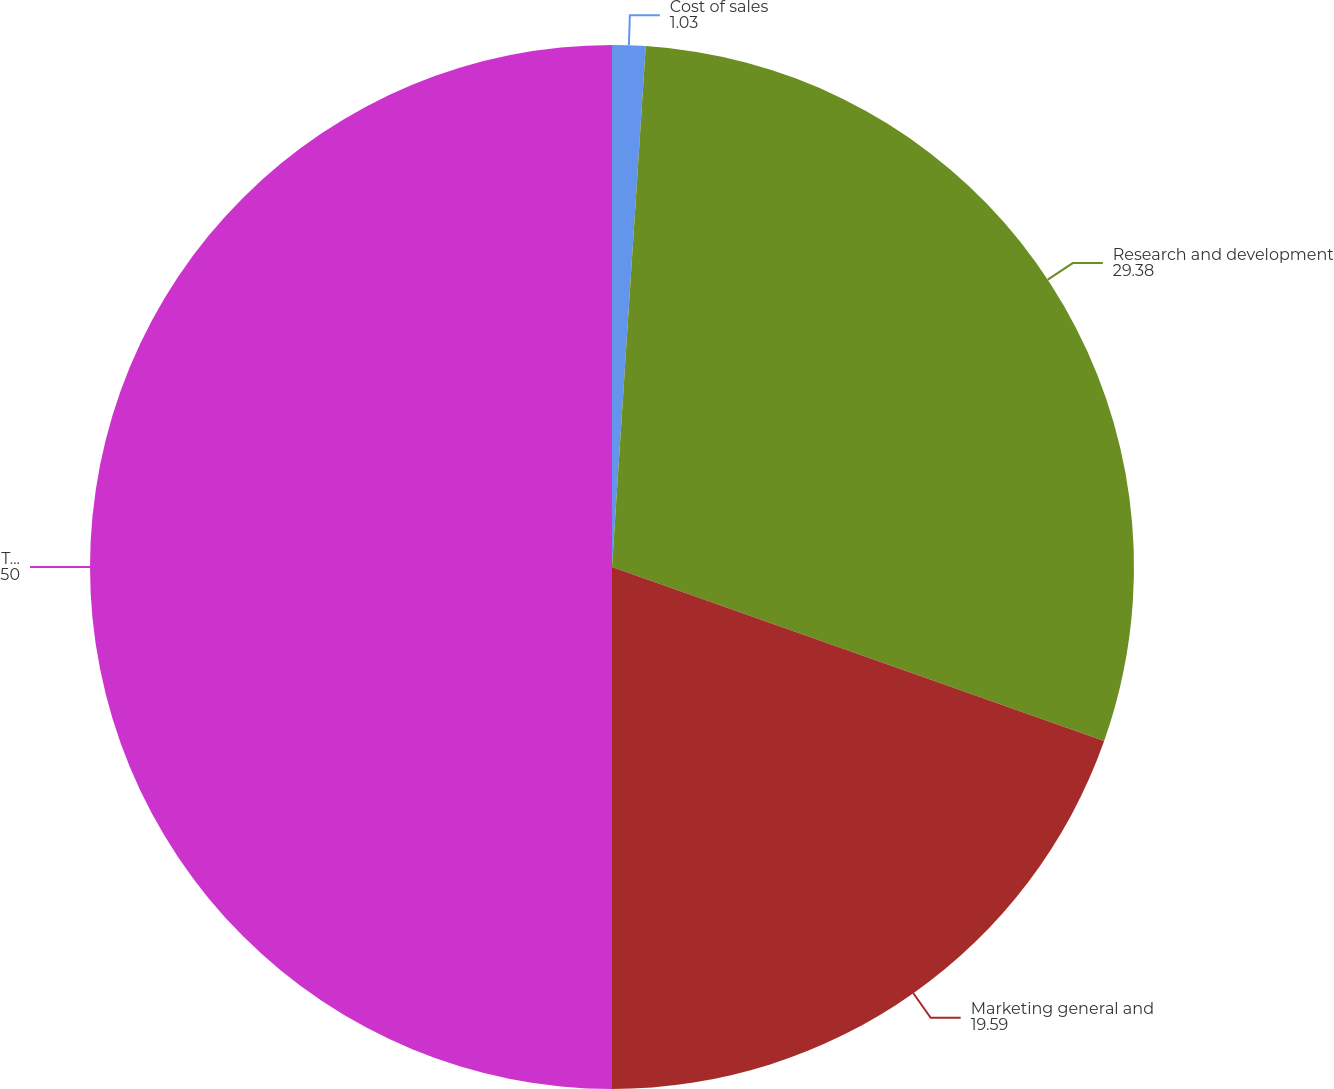<chart> <loc_0><loc_0><loc_500><loc_500><pie_chart><fcel>Cost of sales<fcel>Research and development<fcel>Marketing general and<fcel>Total stock-based compensation<nl><fcel>1.03%<fcel>29.38%<fcel>19.59%<fcel>50.0%<nl></chart> 